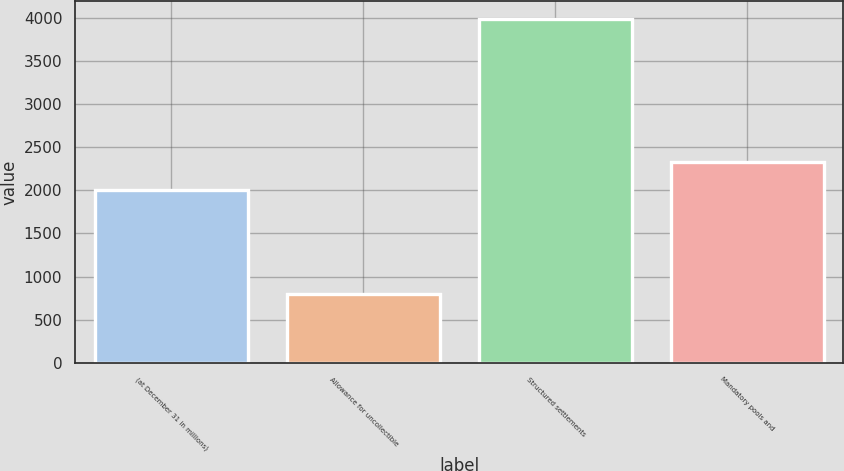Convert chart. <chart><loc_0><loc_0><loc_500><loc_500><bar_chart><fcel>(at December 31 in millions)<fcel>Allowance for uncollectible<fcel>Structured settlements<fcel>Mandatory pools and<nl><fcel>2005<fcel>804<fcel>3990<fcel>2323.6<nl></chart> 